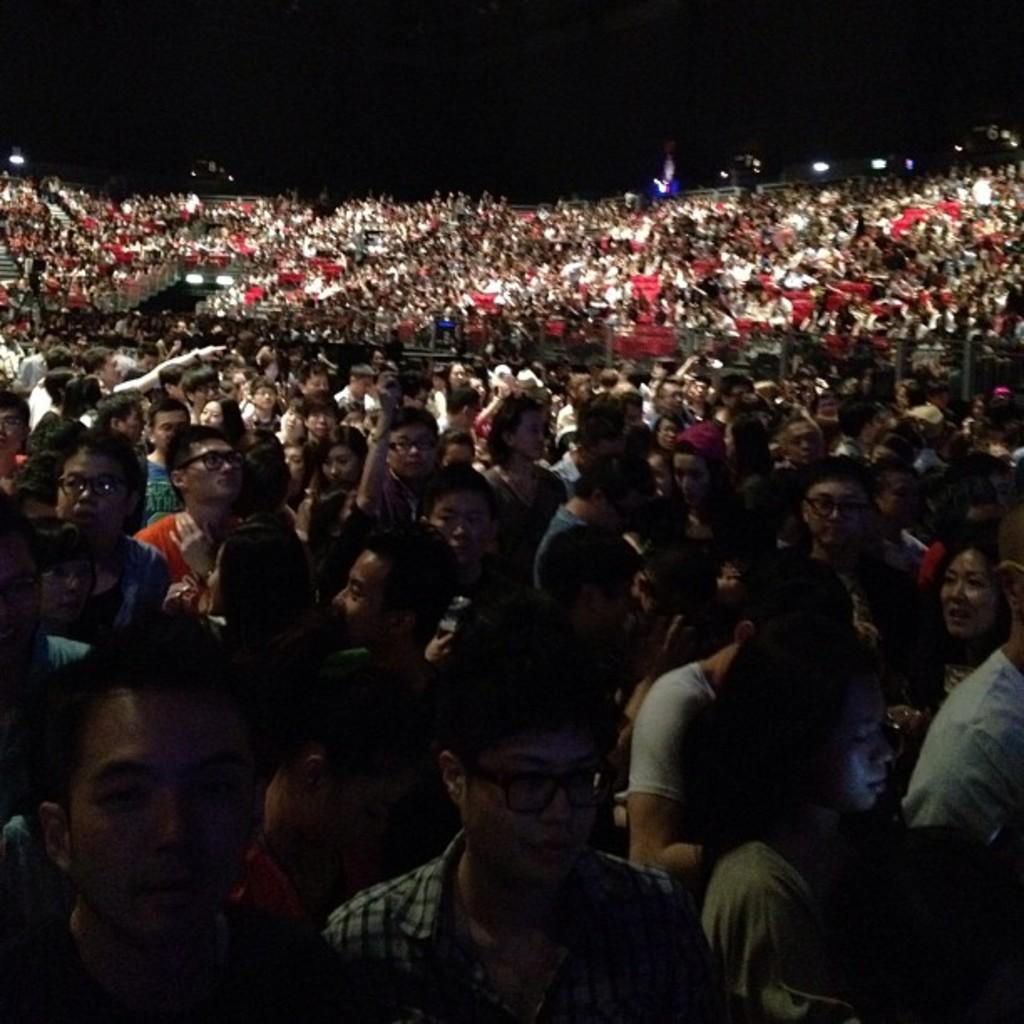How would you summarize this image in a sentence or two? In the image in the center, we can see a group of people are standing. In the background we can see the lights. 